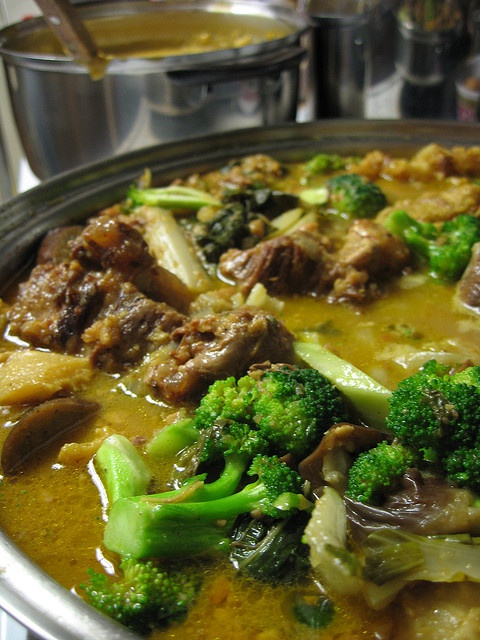Describe the objects in this image and their specific colors. I can see bowl in darkgray, gray, black, and olive tones, broccoli in darkgray, black, darkgreen, green, and lightgreen tones, broccoli in darkgray, black, darkgreen, and olive tones, broccoli in darkgray, black, olive, and darkgreen tones, and broccoli in darkgray, black, darkgreen, and green tones in this image. 